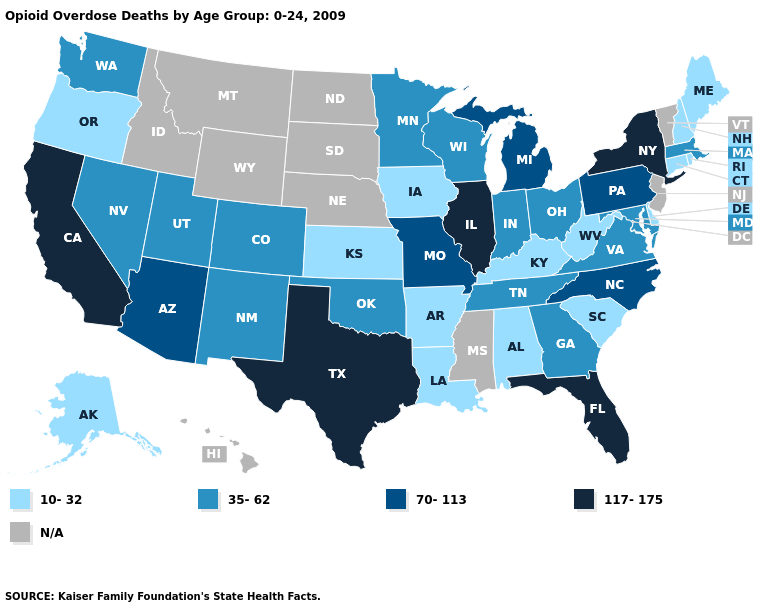What is the lowest value in the South?
Answer briefly. 10-32. What is the lowest value in states that border Nevada?
Give a very brief answer. 10-32. Does California have the highest value in the USA?
Concise answer only. Yes. What is the value of Rhode Island?
Give a very brief answer. 10-32. What is the value of Hawaii?
Short answer required. N/A. Does the map have missing data?
Concise answer only. Yes. How many symbols are there in the legend?
Answer briefly. 5. What is the highest value in states that border Wisconsin?
Be succinct. 117-175. Name the states that have a value in the range 10-32?
Answer briefly. Alabama, Alaska, Arkansas, Connecticut, Delaware, Iowa, Kansas, Kentucky, Louisiana, Maine, New Hampshire, Oregon, Rhode Island, South Carolina, West Virginia. What is the lowest value in the South?
Be succinct. 10-32. What is the value of Alabama?
Concise answer only. 10-32. Does California have the highest value in the West?
Give a very brief answer. Yes. What is the lowest value in the West?
Be succinct. 10-32. Is the legend a continuous bar?
Be succinct. No. Does the first symbol in the legend represent the smallest category?
Keep it brief. Yes. 